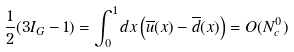Convert formula to latex. <formula><loc_0><loc_0><loc_500><loc_500>\frac { 1 } { 2 } ( 3 I _ { G } - 1 ) = \int _ { 0 } ^ { 1 } d x \left ( \overline { u } ( x ) - \overline { d } ( x ) \right ) = O ( N _ { c } ^ { 0 } )</formula> 